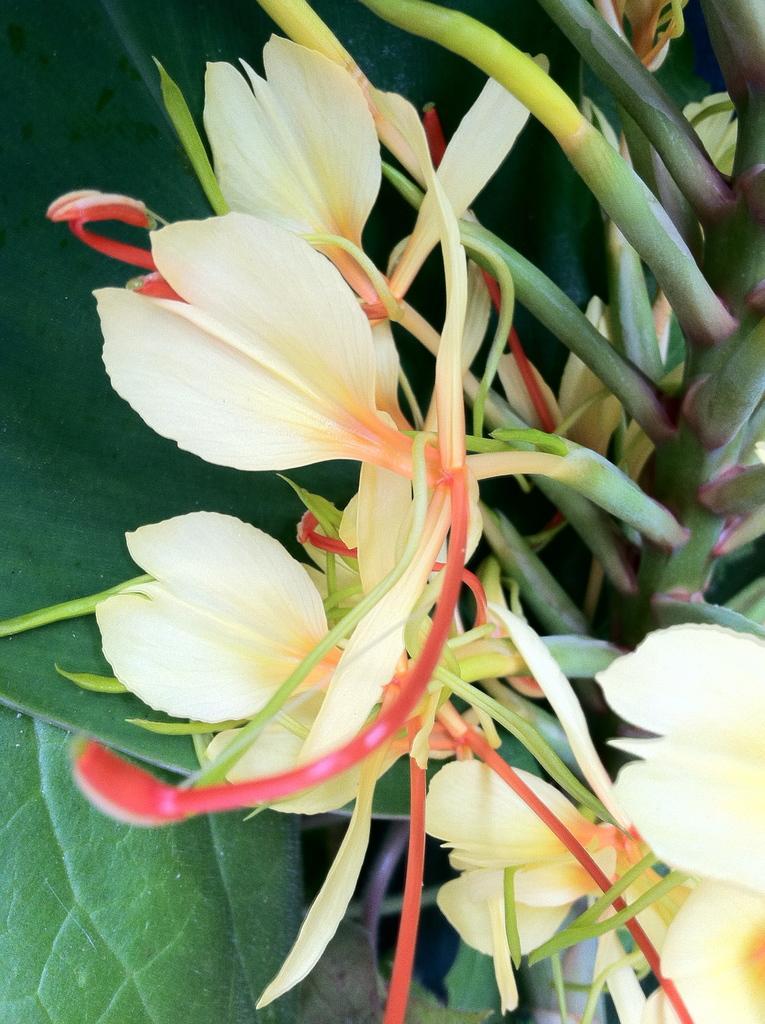Please provide a concise description of this image. In this image I can see flowers and stem and leaves visible. 